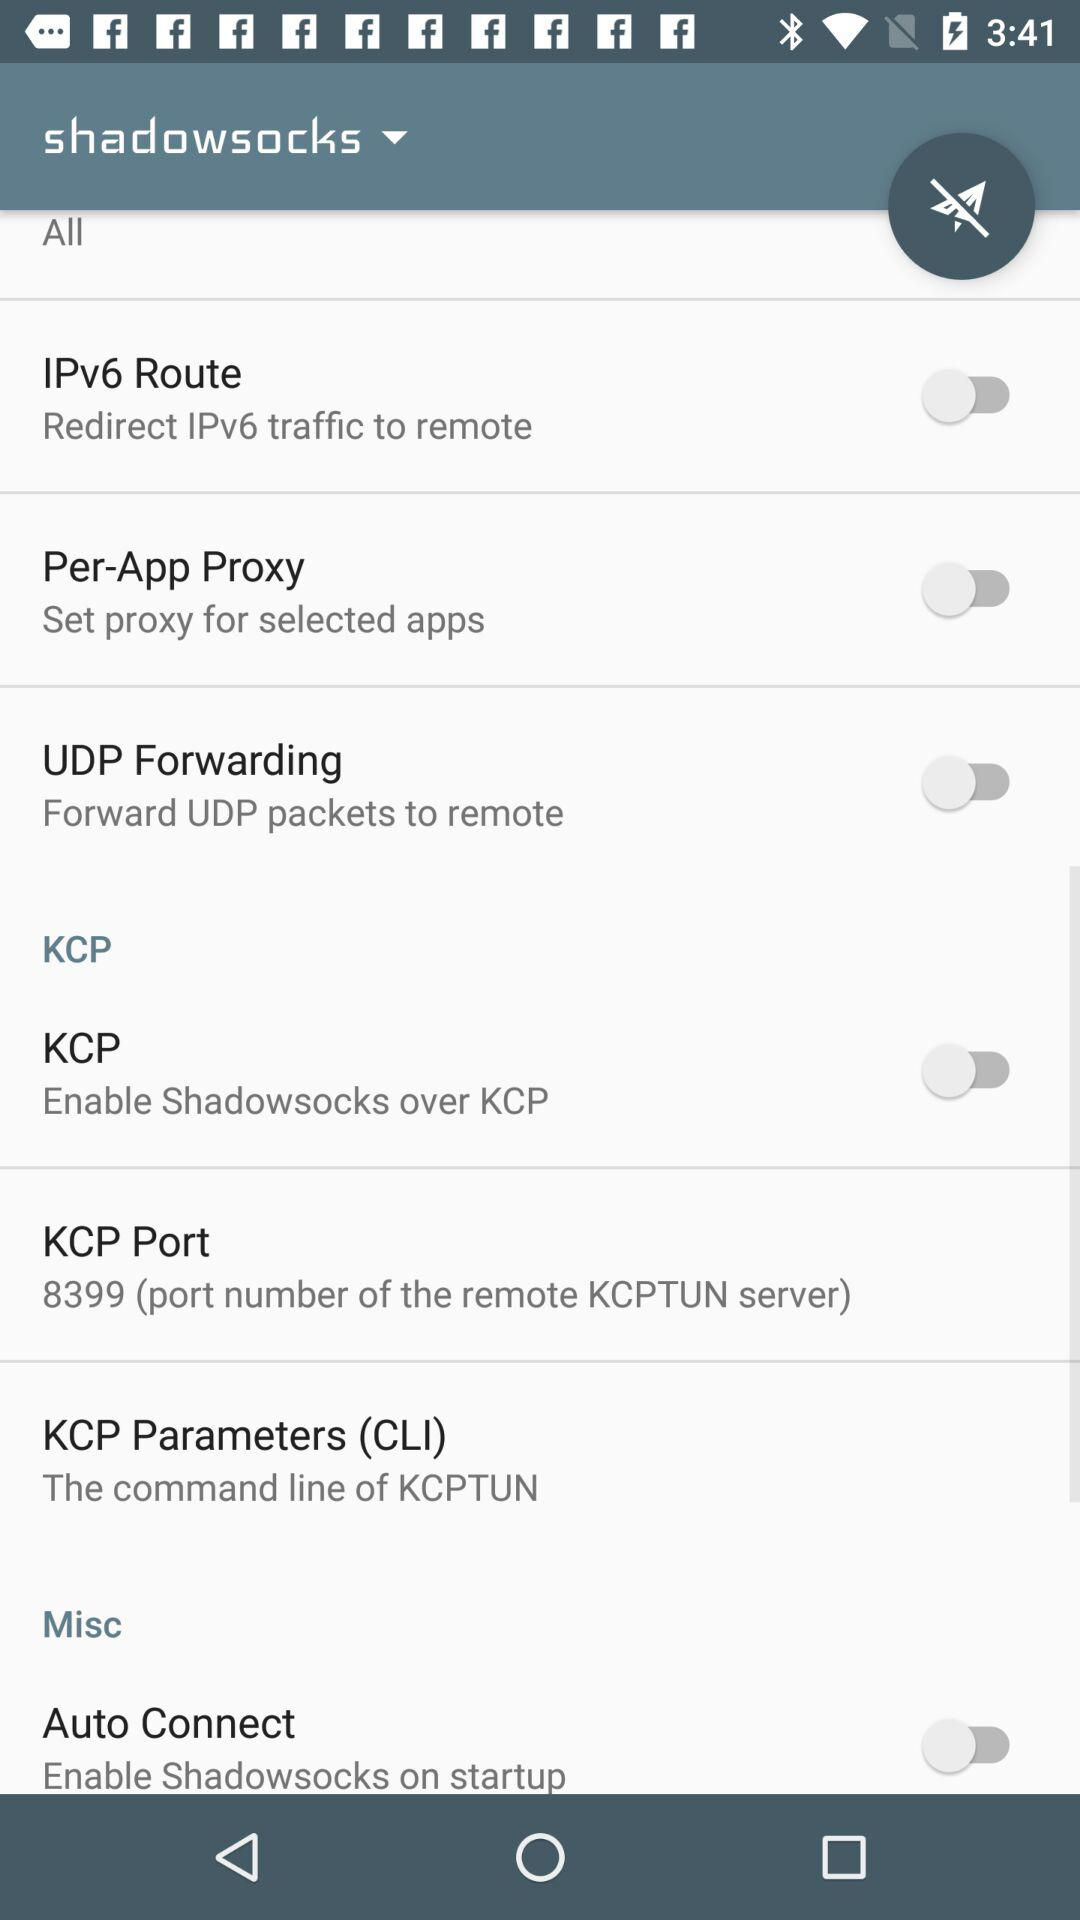What is the application name?
When the provided information is insufficient, respond with <no answer>. <no answer> 